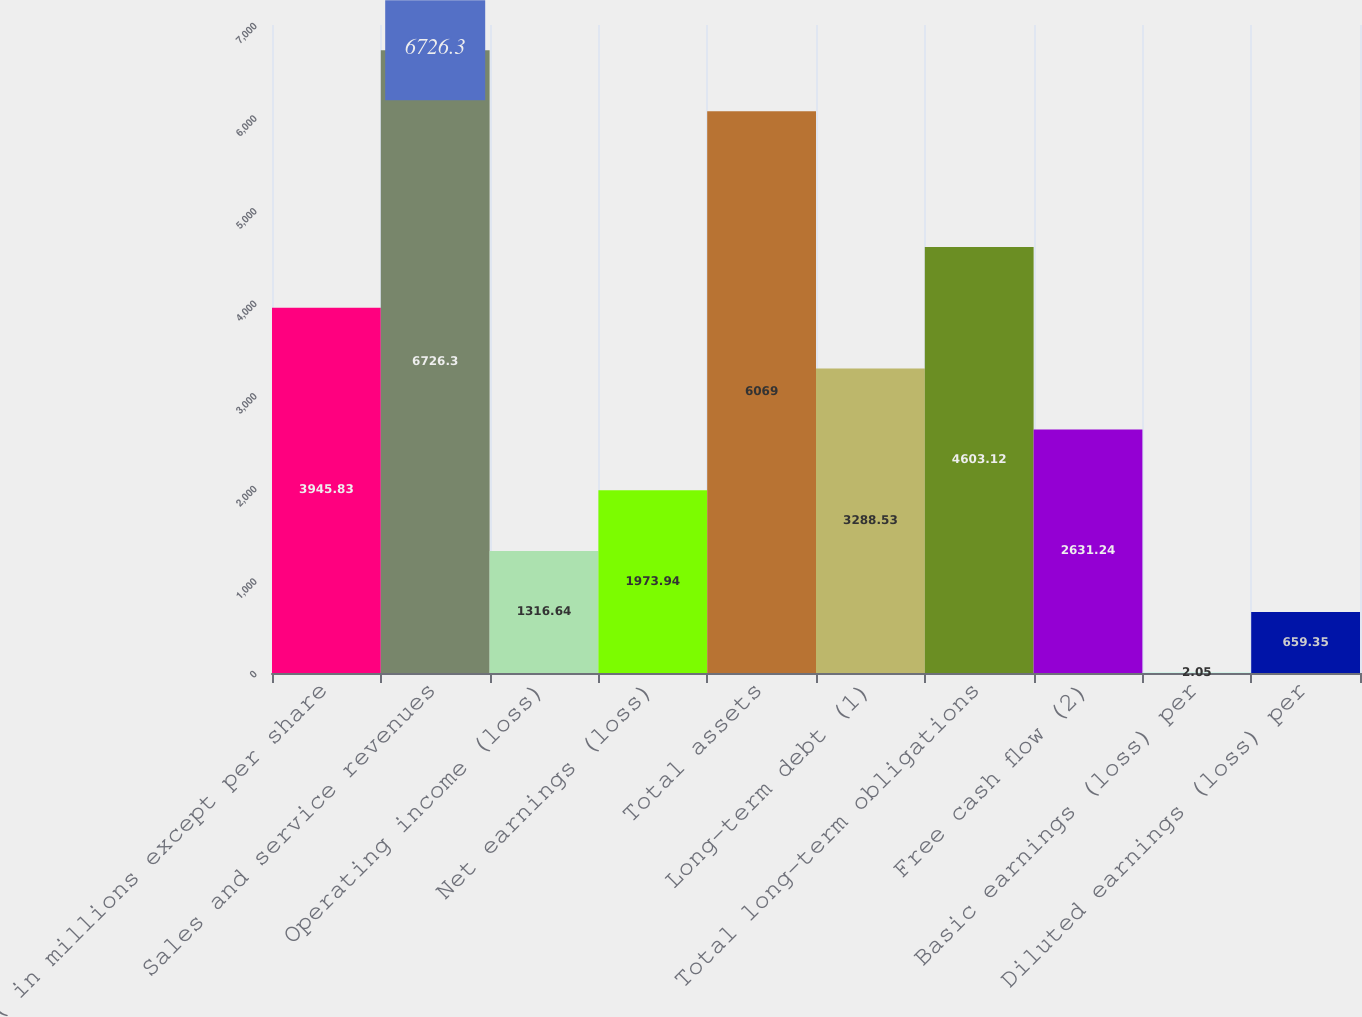<chart> <loc_0><loc_0><loc_500><loc_500><bar_chart><fcel>( in millions except per share<fcel>Sales and service revenues<fcel>Operating income (loss)<fcel>Net earnings (loss)<fcel>Total assets<fcel>Long-term debt (1)<fcel>Total long-term obligations<fcel>Free cash flow (2)<fcel>Basic earnings (loss) per<fcel>Diluted earnings (loss) per<nl><fcel>3945.83<fcel>6726.3<fcel>1316.64<fcel>1973.94<fcel>6069<fcel>3288.53<fcel>4603.12<fcel>2631.24<fcel>2.05<fcel>659.35<nl></chart> 